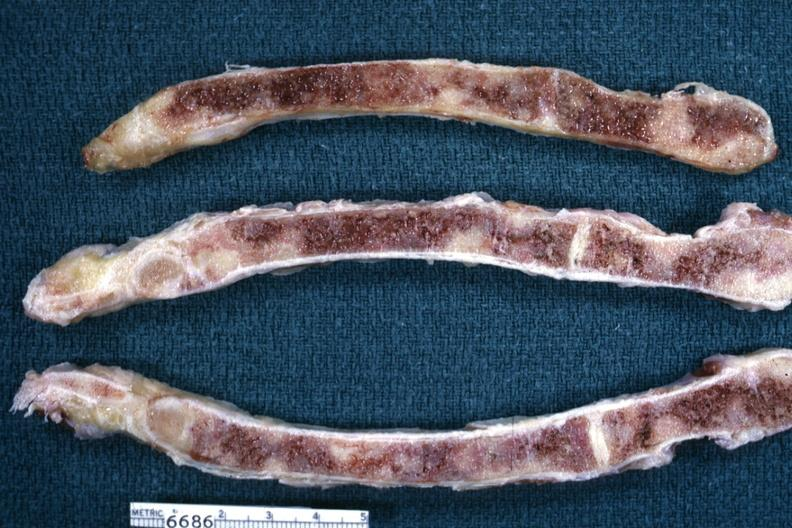what is present?
Answer the question using a single word or phrase. Joints 